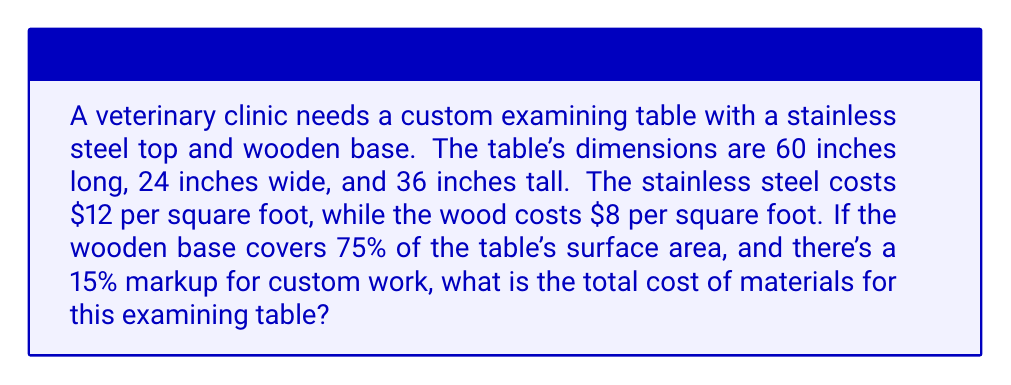Can you answer this question? 1. Calculate the total surface area of the table:
   Top: $60 \times 24 = 1440$ sq inches
   Sides: $2(60 \times 36) + 2(24 \times 36) = 6048$ sq inches
   Total: $1440 + 6048 = 7488$ sq inches

2. Convert to square feet:
   $7488 \div 144 = 52$ sq ft

3. Calculate the area of stainless steel (25% of total):
   $52 \times 0.25 = 13$ sq ft

4. Calculate the area of wood (75% of total):
   $52 \times 0.75 = 39$ sq ft

5. Calculate the cost of stainless steel:
   $13 \times \$12 = \$156$

6. Calculate the cost of wood:
   $39 \times \$8 = \$312$

7. Sum up the material costs:
   $\$156 + \$312 = \$468$

8. Apply the 15% markup:
   $\$468 \times 1.15 = \$538.20$

Therefore, the total cost of materials for the custom veterinary examining table is $\$538.20$.
Answer: $538.20 